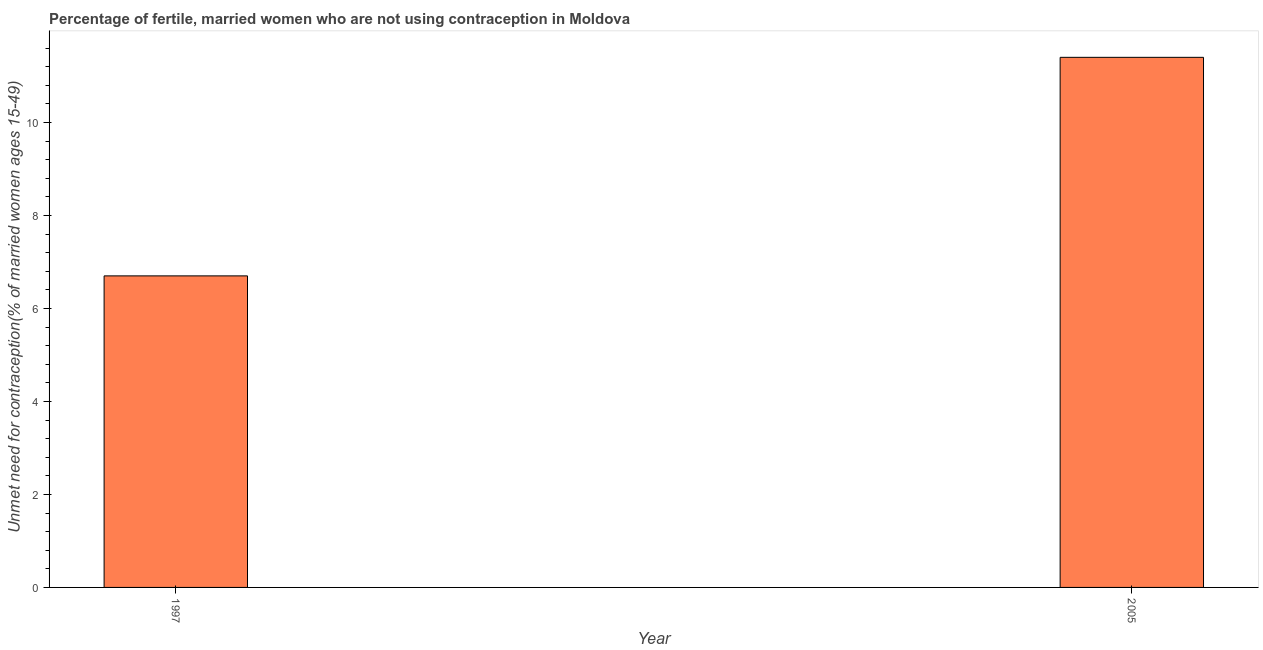Does the graph contain any zero values?
Give a very brief answer. No. What is the title of the graph?
Provide a succinct answer. Percentage of fertile, married women who are not using contraception in Moldova. What is the label or title of the X-axis?
Give a very brief answer. Year. What is the label or title of the Y-axis?
Keep it short and to the point.  Unmet need for contraception(% of married women ages 15-49). In which year was the number of married women who are not using contraception maximum?
Make the answer very short. 2005. What is the sum of the number of married women who are not using contraception?
Provide a short and direct response. 18.1. What is the difference between the number of married women who are not using contraception in 1997 and 2005?
Provide a succinct answer. -4.7. What is the average number of married women who are not using contraception per year?
Your answer should be compact. 9.05. What is the median number of married women who are not using contraception?
Offer a terse response. 9.05. In how many years, is the number of married women who are not using contraception greater than 6.8 %?
Your answer should be compact. 1. What is the ratio of the number of married women who are not using contraception in 1997 to that in 2005?
Your response must be concise. 0.59. How many bars are there?
Provide a succinct answer. 2. What is the difference between two consecutive major ticks on the Y-axis?
Make the answer very short. 2. What is the ratio of the  Unmet need for contraception(% of married women ages 15-49) in 1997 to that in 2005?
Offer a terse response. 0.59. 